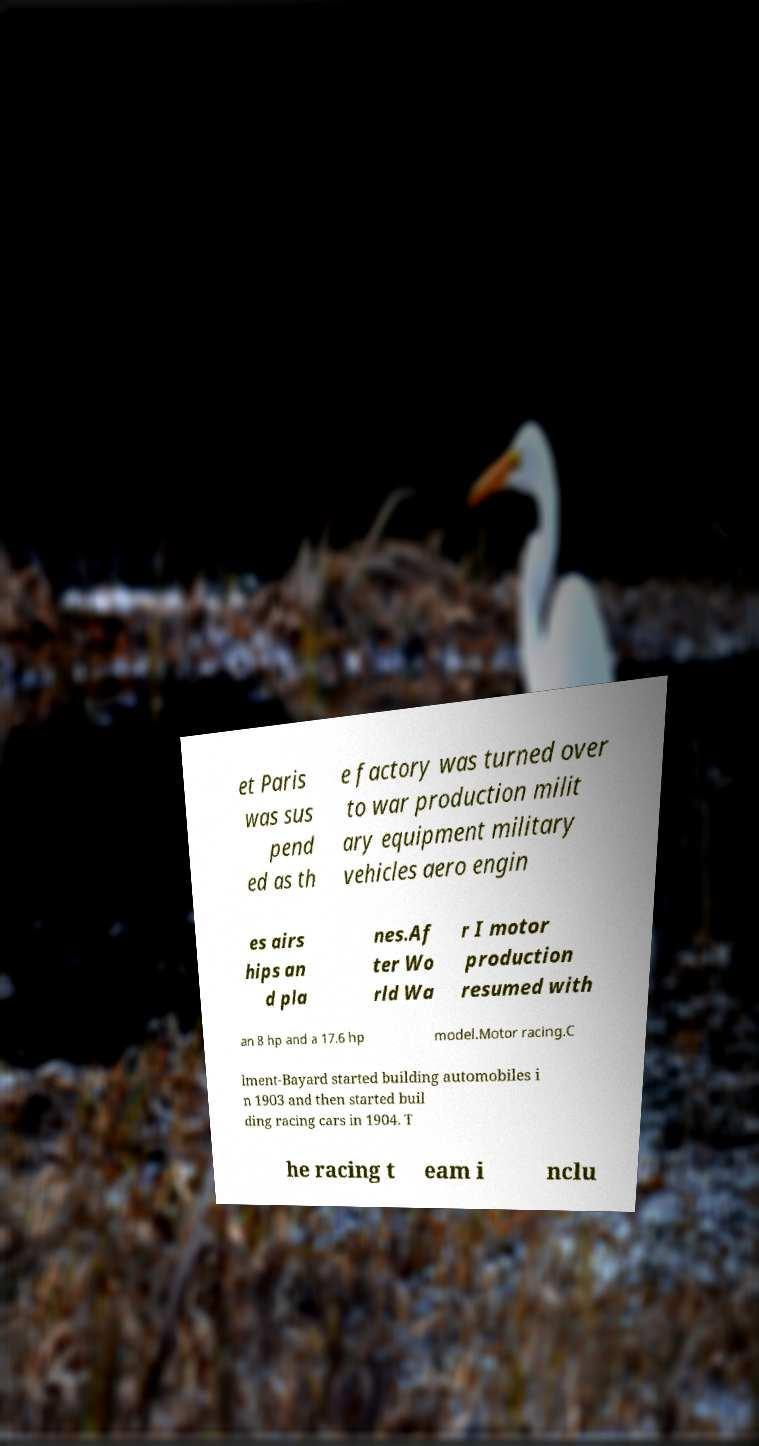Please read and relay the text visible in this image. What does it say? et Paris was sus pend ed as th e factory was turned over to war production milit ary equipment military vehicles aero engin es airs hips an d pla nes.Af ter Wo rld Wa r I motor production resumed with an 8 hp and a 17.6 hp model.Motor racing.C lment-Bayard started building automobiles i n 1903 and then started buil ding racing cars in 1904. T he racing t eam i nclu 